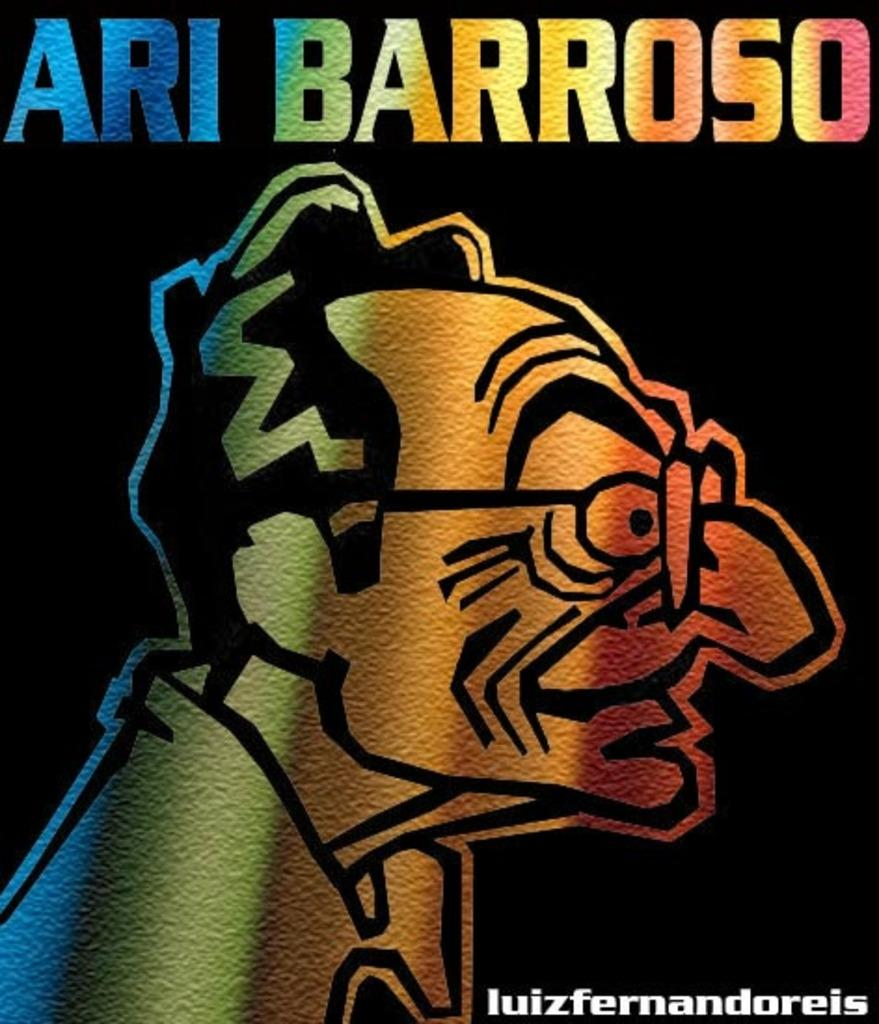Provide a one-sentence caption for the provided image. A very colorful and drawn cartoon picture of Ari Barroso. 